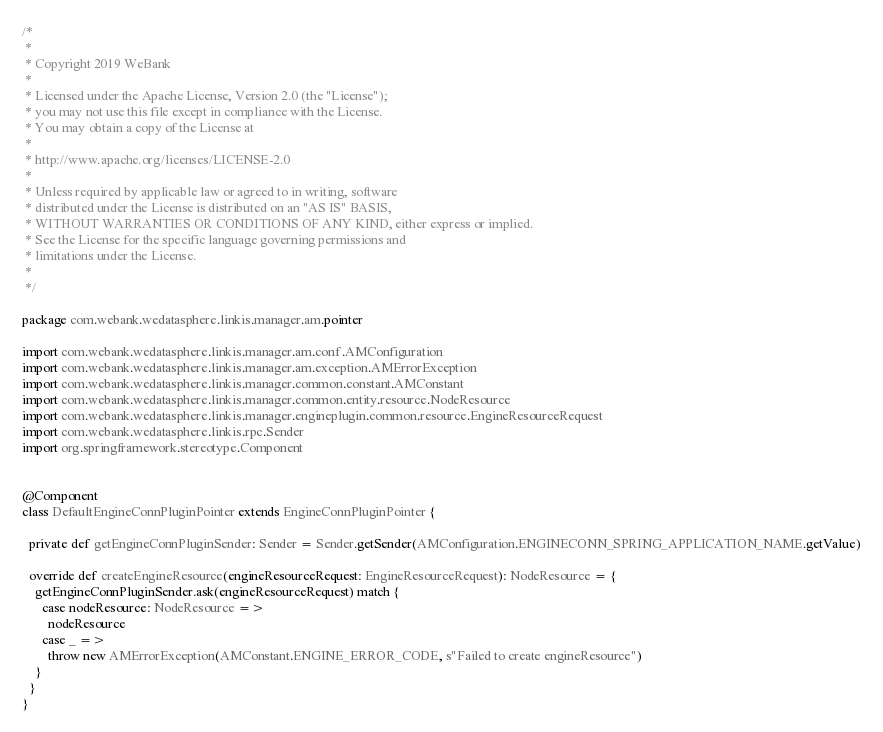<code> <loc_0><loc_0><loc_500><loc_500><_Scala_>/*
 *
 * Copyright 2019 WeBank
 *
 * Licensed under the Apache License, Version 2.0 (the "License");
 * you may not use this file except in compliance with the License.
 * You may obtain a copy of the License at
 *
 * http://www.apache.org/licenses/LICENSE-2.0
 *
 * Unless required by applicable law or agreed to in writing, software
 * distributed under the License is distributed on an "AS IS" BASIS,
 * WITHOUT WARRANTIES OR CONDITIONS OF ANY KIND, either express or implied.
 * See the License for the specific language governing permissions and
 * limitations under the License.
 *
 */

package com.webank.wedatasphere.linkis.manager.am.pointer

import com.webank.wedatasphere.linkis.manager.am.conf.AMConfiguration
import com.webank.wedatasphere.linkis.manager.am.exception.AMErrorException
import com.webank.wedatasphere.linkis.manager.common.constant.AMConstant
import com.webank.wedatasphere.linkis.manager.common.entity.resource.NodeResource
import com.webank.wedatasphere.linkis.manager.engineplugin.common.resource.EngineResourceRequest
import com.webank.wedatasphere.linkis.rpc.Sender
import org.springframework.stereotype.Component


@Component
class DefaultEngineConnPluginPointer extends EngineConnPluginPointer {

  private def getEngineConnPluginSender: Sender = Sender.getSender(AMConfiguration.ENGINECONN_SPRING_APPLICATION_NAME.getValue)

  override def createEngineResource(engineResourceRequest: EngineResourceRequest): NodeResource = {
    getEngineConnPluginSender.ask(engineResourceRequest) match {
      case nodeResource: NodeResource =>
        nodeResource
      case _ =>
        throw new AMErrorException(AMConstant.ENGINE_ERROR_CODE, s"Failed to create engineResource")
    }
  }
}
</code> 